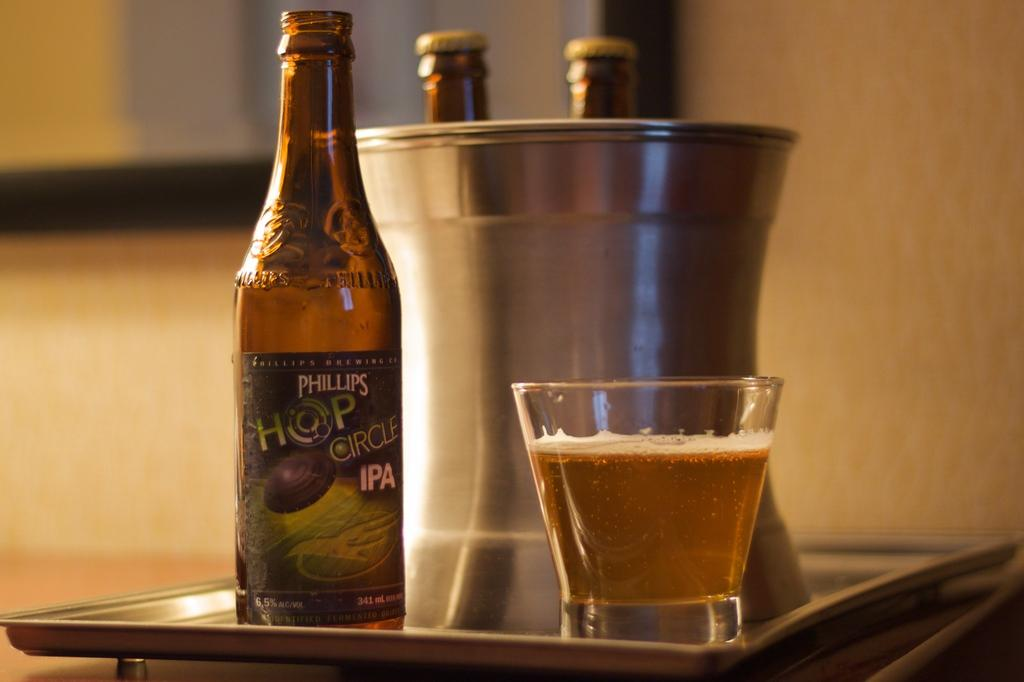<image>
Offer a succinct explanation of the picture presented. A beer bottle that says Phillips Hop Circle IPA is next to a glass of beer. 